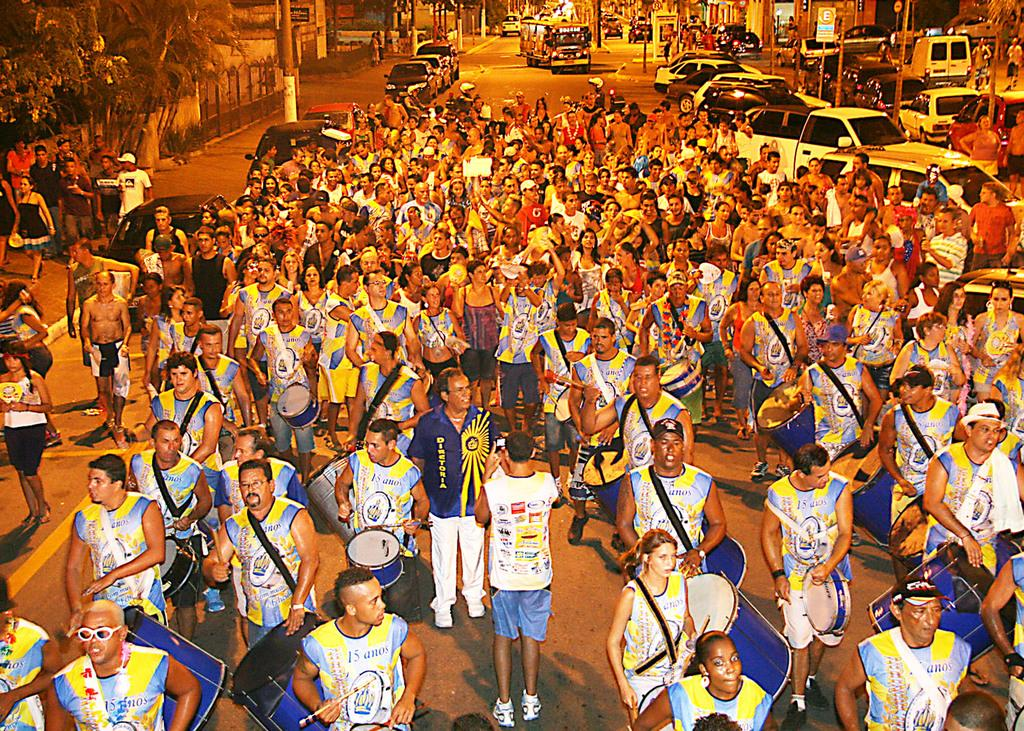What can be seen on the path in the image? There are many people on the path in the image. What is visible in the background of the image? There are vehicles, poles, and buildings in the background of the image. What type of trousers is the bee wearing on its arm in the image? There is no bee or trousers present in the image. How many arms does the bee have in the image? There is no bee present in the image, so it is not possible to determine the number of arms it might have. 